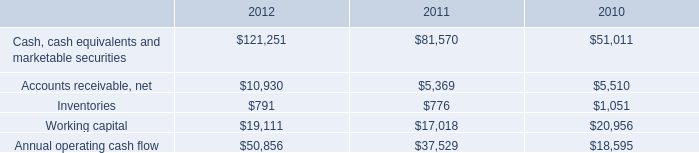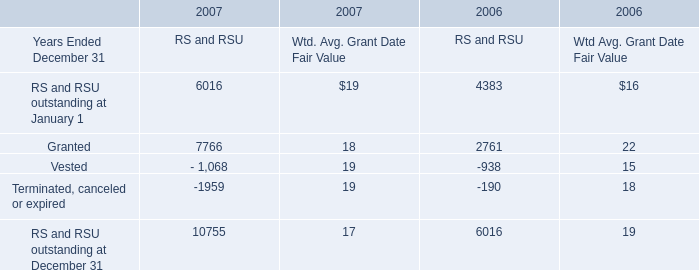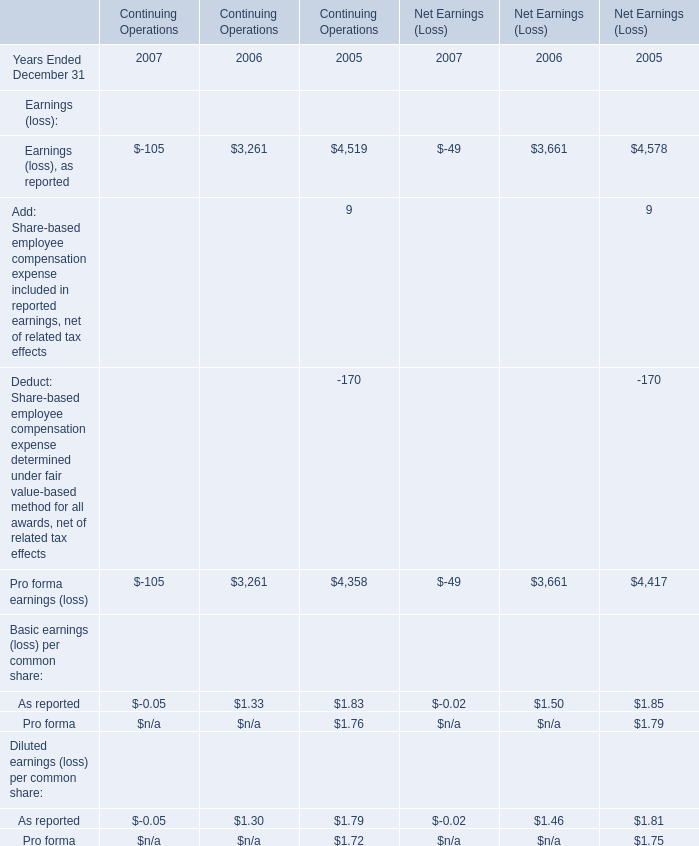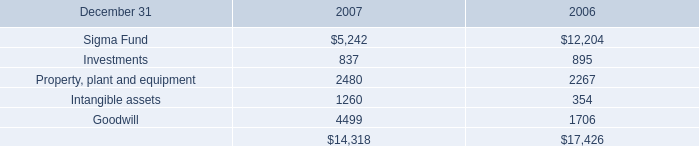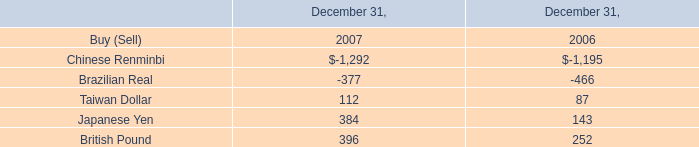what was the percentage change in the annual operating cash flow between 2011 and 2012? 
Computations: ((50856 - 37529) / 37529)
Answer: 0.35511. 